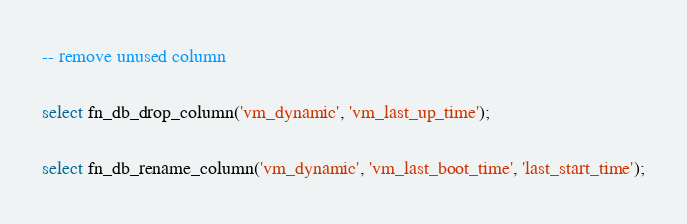<code> <loc_0><loc_0><loc_500><loc_500><_SQL_>-- remove unused column

select fn_db_drop_column('vm_dynamic', 'vm_last_up_time');

select fn_db_rename_column('vm_dynamic', 'vm_last_boot_time', 'last_start_time');

</code> 